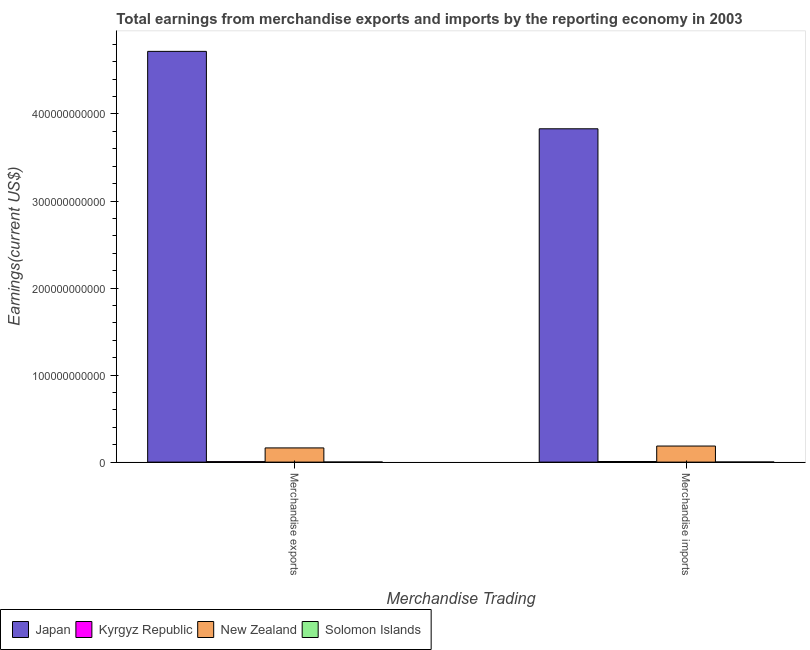How many bars are there on the 1st tick from the left?
Offer a terse response. 4. What is the earnings from merchandise imports in Kyrgyz Republic?
Give a very brief answer. 7.17e+08. Across all countries, what is the maximum earnings from merchandise exports?
Your response must be concise. 4.72e+11. Across all countries, what is the minimum earnings from merchandise imports?
Your answer should be compact. 1.35e+08. In which country was the earnings from merchandise exports minimum?
Offer a very short reply. Solomon Islands. What is the total earnings from merchandise exports in the graph?
Give a very brief answer. 4.89e+11. What is the difference between the earnings from merchandise imports in Kyrgyz Republic and that in Japan?
Your answer should be very brief. -3.82e+11. What is the difference between the earnings from merchandise imports in Solomon Islands and the earnings from merchandise exports in Japan?
Provide a succinct answer. -4.72e+11. What is the average earnings from merchandise imports per country?
Offer a very short reply. 1.01e+11. What is the difference between the earnings from merchandise exports and earnings from merchandise imports in Japan?
Your answer should be very brief. 8.90e+1. What is the ratio of the earnings from merchandise imports in Japan to that in New Zealand?
Offer a terse response. 20.73. In how many countries, is the earnings from merchandise exports greater than the average earnings from merchandise exports taken over all countries?
Offer a very short reply. 1. What does the 3rd bar from the right in Merchandise imports represents?
Your answer should be very brief. Kyrgyz Republic. How many bars are there?
Give a very brief answer. 8. Are all the bars in the graph horizontal?
Give a very brief answer. No. How many countries are there in the graph?
Your response must be concise. 4. What is the difference between two consecutive major ticks on the Y-axis?
Make the answer very short. 1.00e+11. Are the values on the major ticks of Y-axis written in scientific E-notation?
Make the answer very short. No. How many legend labels are there?
Your answer should be compact. 4. What is the title of the graph?
Ensure brevity in your answer.  Total earnings from merchandise exports and imports by the reporting economy in 2003. Does "American Samoa" appear as one of the legend labels in the graph?
Ensure brevity in your answer.  No. What is the label or title of the X-axis?
Provide a short and direct response. Merchandise Trading. What is the label or title of the Y-axis?
Ensure brevity in your answer.  Earnings(current US$). What is the Earnings(current US$) of Japan in Merchandise exports?
Your response must be concise. 4.72e+11. What is the Earnings(current US$) of Kyrgyz Republic in Merchandise exports?
Give a very brief answer. 5.81e+08. What is the Earnings(current US$) of New Zealand in Merchandise exports?
Give a very brief answer. 1.63e+1. What is the Earnings(current US$) of Solomon Islands in Merchandise exports?
Offer a very short reply. 1.23e+08. What is the Earnings(current US$) in Japan in Merchandise imports?
Your answer should be compact. 3.83e+11. What is the Earnings(current US$) of Kyrgyz Republic in Merchandise imports?
Your response must be concise. 7.17e+08. What is the Earnings(current US$) of New Zealand in Merchandise imports?
Provide a succinct answer. 1.85e+1. What is the Earnings(current US$) of Solomon Islands in Merchandise imports?
Offer a terse response. 1.35e+08. Across all Merchandise Trading, what is the maximum Earnings(current US$) of Japan?
Provide a short and direct response. 4.72e+11. Across all Merchandise Trading, what is the maximum Earnings(current US$) of Kyrgyz Republic?
Keep it short and to the point. 7.17e+08. Across all Merchandise Trading, what is the maximum Earnings(current US$) of New Zealand?
Your response must be concise. 1.85e+1. Across all Merchandise Trading, what is the maximum Earnings(current US$) of Solomon Islands?
Keep it short and to the point. 1.35e+08. Across all Merchandise Trading, what is the minimum Earnings(current US$) in Japan?
Your answer should be very brief. 3.83e+11. Across all Merchandise Trading, what is the minimum Earnings(current US$) in Kyrgyz Republic?
Make the answer very short. 5.81e+08. Across all Merchandise Trading, what is the minimum Earnings(current US$) in New Zealand?
Keep it short and to the point. 1.63e+1. Across all Merchandise Trading, what is the minimum Earnings(current US$) of Solomon Islands?
Offer a terse response. 1.23e+08. What is the total Earnings(current US$) in Japan in the graph?
Provide a short and direct response. 8.55e+11. What is the total Earnings(current US$) of Kyrgyz Republic in the graph?
Offer a very short reply. 1.30e+09. What is the total Earnings(current US$) in New Zealand in the graph?
Your answer should be very brief. 3.48e+1. What is the total Earnings(current US$) of Solomon Islands in the graph?
Your answer should be compact. 2.58e+08. What is the difference between the Earnings(current US$) in Japan in Merchandise exports and that in Merchandise imports?
Give a very brief answer. 8.90e+1. What is the difference between the Earnings(current US$) of Kyrgyz Republic in Merchandise exports and that in Merchandise imports?
Provide a short and direct response. -1.36e+08. What is the difference between the Earnings(current US$) of New Zealand in Merchandise exports and that in Merchandise imports?
Make the answer very short. -2.15e+09. What is the difference between the Earnings(current US$) of Solomon Islands in Merchandise exports and that in Merchandise imports?
Give a very brief answer. -1.20e+07. What is the difference between the Earnings(current US$) in Japan in Merchandise exports and the Earnings(current US$) in Kyrgyz Republic in Merchandise imports?
Make the answer very short. 4.71e+11. What is the difference between the Earnings(current US$) in Japan in Merchandise exports and the Earnings(current US$) in New Zealand in Merchandise imports?
Provide a succinct answer. 4.53e+11. What is the difference between the Earnings(current US$) in Japan in Merchandise exports and the Earnings(current US$) in Solomon Islands in Merchandise imports?
Your answer should be compact. 4.72e+11. What is the difference between the Earnings(current US$) in Kyrgyz Republic in Merchandise exports and the Earnings(current US$) in New Zealand in Merchandise imports?
Give a very brief answer. -1.79e+1. What is the difference between the Earnings(current US$) of Kyrgyz Republic in Merchandise exports and the Earnings(current US$) of Solomon Islands in Merchandise imports?
Offer a very short reply. 4.46e+08. What is the difference between the Earnings(current US$) in New Zealand in Merchandise exports and the Earnings(current US$) in Solomon Islands in Merchandise imports?
Make the answer very short. 1.62e+1. What is the average Earnings(current US$) of Japan per Merchandise Trading?
Offer a very short reply. 4.27e+11. What is the average Earnings(current US$) in Kyrgyz Republic per Merchandise Trading?
Offer a terse response. 6.49e+08. What is the average Earnings(current US$) in New Zealand per Merchandise Trading?
Provide a succinct answer. 1.74e+1. What is the average Earnings(current US$) in Solomon Islands per Merchandise Trading?
Ensure brevity in your answer.  1.29e+08. What is the difference between the Earnings(current US$) of Japan and Earnings(current US$) of Kyrgyz Republic in Merchandise exports?
Provide a short and direct response. 4.71e+11. What is the difference between the Earnings(current US$) in Japan and Earnings(current US$) in New Zealand in Merchandise exports?
Your answer should be compact. 4.56e+11. What is the difference between the Earnings(current US$) in Japan and Earnings(current US$) in Solomon Islands in Merchandise exports?
Provide a short and direct response. 4.72e+11. What is the difference between the Earnings(current US$) in Kyrgyz Republic and Earnings(current US$) in New Zealand in Merchandise exports?
Provide a succinct answer. -1.57e+1. What is the difference between the Earnings(current US$) in Kyrgyz Republic and Earnings(current US$) in Solomon Islands in Merchandise exports?
Offer a terse response. 4.58e+08. What is the difference between the Earnings(current US$) in New Zealand and Earnings(current US$) in Solomon Islands in Merchandise exports?
Your response must be concise. 1.62e+1. What is the difference between the Earnings(current US$) of Japan and Earnings(current US$) of Kyrgyz Republic in Merchandise imports?
Offer a terse response. 3.82e+11. What is the difference between the Earnings(current US$) in Japan and Earnings(current US$) in New Zealand in Merchandise imports?
Give a very brief answer. 3.64e+11. What is the difference between the Earnings(current US$) of Japan and Earnings(current US$) of Solomon Islands in Merchandise imports?
Your answer should be compact. 3.83e+11. What is the difference between the Earnings(current US$) of Kyrgyz Republic and Earnings(current US$) of New Zealand in Merchandise imports?
Give a very brief answer. -1.78e+1. What is the difference between the Earnings(current US$) in Kyrgyz Republic and Earnings(current US$) in Solomon Islands in Merchandise imports?
Your answer should be very brief. 5.82e+08. What is the difference between the Earnings(current US$) in New Zealand and Earnings(current US$) in Solomon Islands in Merchandise imports?
Provide a succinct answer. 1.83e+1. What is the ratio of the Earnings(current US$) of Japan in Merchandise exports to that in Merchandise imports?
Your response must be concise. 1.23. What is the ratio of the Earnings(current US$) in Kyrgyz Republic in Merchandise exports to that in Merchandise imports?
Provide a succinct answer. 0.81. What is the ratio of the Earnings(current US$) of New Zealand in Merchandise exports to that in Merchandise imports?
Your answer should be compact. 0.88. What is the ratio of the Earnings(current US$) of Solomon Islands in Merchandise exports to that in Merchandise imports?
Your response must be concise. 0.91. What is the difference between the highest and the second highest Earnings(current US$) in Japan?
Provide a short and direct response. 8.90e+1. What is the difference between the highest and the second highest Earnings(current US$) in Kyrgyz Republic?
Provide a succinct answer. 1.36e+08. What is the difference between the highest and the second highest Earnings(current US$) of New Zealand?
Offer a very short reply. 2.15e+09. What is the difference between the highest and the second highest Earnings(current US$) in Solomon Islands?
Your answer should be very brief. 1.20e+07. What is the difference between the highest and the lowest Earnings(current US$) in Japan?
Offer a terse response. 8.90e+1. What is the difference between the highest and the lowest Earnings(current US$) in Kyrgyz Republic?
Your response must be concise. 1.36e+08. What is the difference between the highest and the lowest Earnings(current US$) in New Zealand?
Your response must be concise. 2.15e+09. What is the difference between the highest and the lowest Earnings(current US$) in Solomon Islands?
Offer a very short reply. 1.20e+07. 